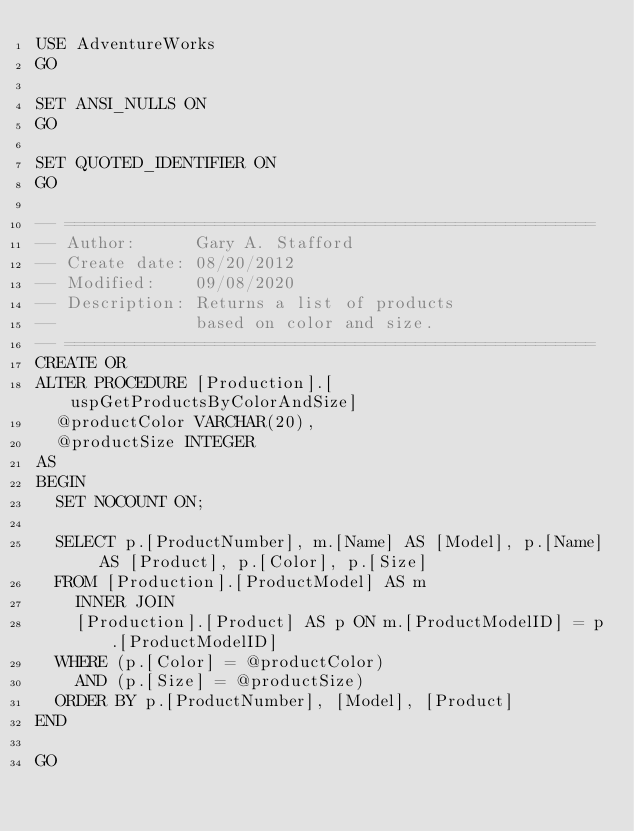Convert code to text. <code><loc_0><loc_0><loc_500><loc_500><_SQL_>USE AdventureWorks
GO

SET ANSI_NULLS ON
GO

SET QUOTED_IDENTIFIER ON
GO

-- =====================================================
-- Author:		Gary A. Stafford
-- Create date: 08/20/2012
-- Modified:    09/08/2020
-- Description:	Returns a list of products
--				based on color and size.
-- =====================================================
CREATE OR
ALTER PROCEDURE [Production].[uspGetProductsByColorAndSize]
  @productColor VARCHAR(20),
  @productSize INTEGER
AS
BEGIN
  SET NOCOUNT ON;

  SELECT p.[ProductNumber], m.[Name] AS [Model], p.[Name] AS [Product], p.[Color], p.[Size]
  FROM [Production].[ProductModel] AS m
    INNER JOIN
    [Production].[Product] AS p ON m.[ProductModelID] = p.[ProductModelID]
  WHERE (p.[Color] = @productColor)
    AND (p.[Size] = @productSize)
  ORDER BY p.[ProductNumber], [Model], [Product]
END

GO


</code> 